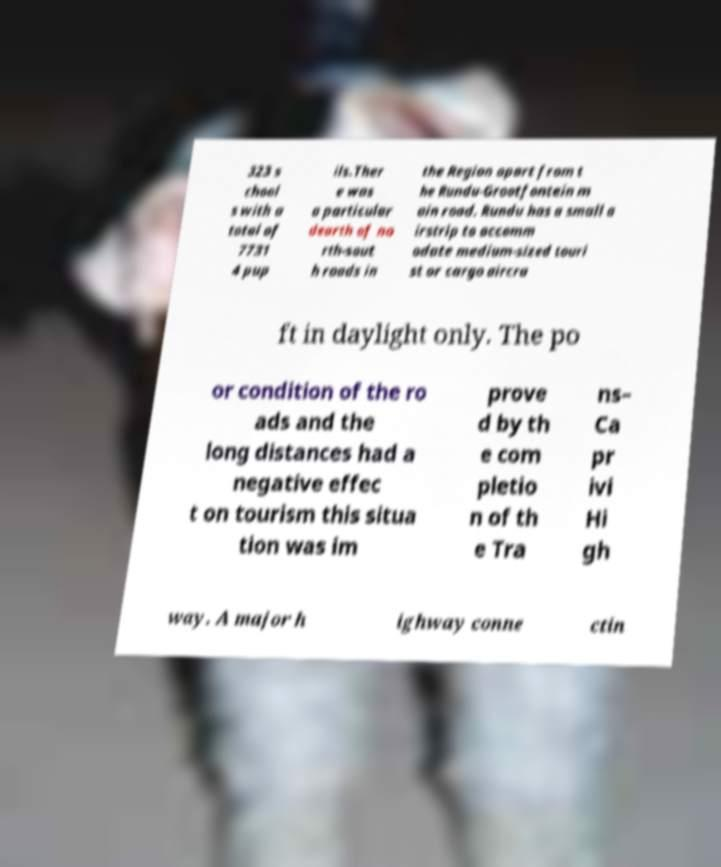Could you extract and type out the text from this image? 323 s chool s with a total of 7731 4 pup ils.Ther e was a particular dearth of no rth-sout h roads in the Region apart from t he Rundu-Grootfontein m ain road. Rundu has a small a irstrip to accomm odate medium-sized touri st or cargo aircra ft in daylight only. The po or condition of the ro ads and the long distances had a negative effec t on tourism this situa tion was im prove d by th e com pletio n of th e Tra ns– Ca pr ivi Hi gh way. A major h ighway conne ctin 